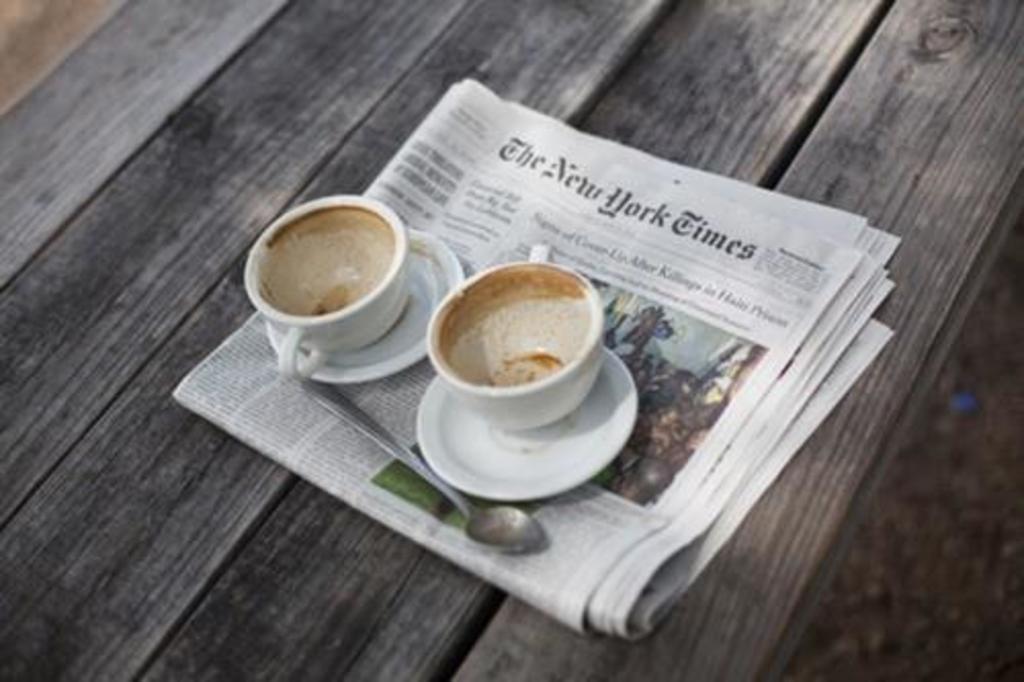Can you describe this image briefly? In this image there is a table on that table there is a news paper on that news paper there is a spoon ,there are two cups and two saucers. 